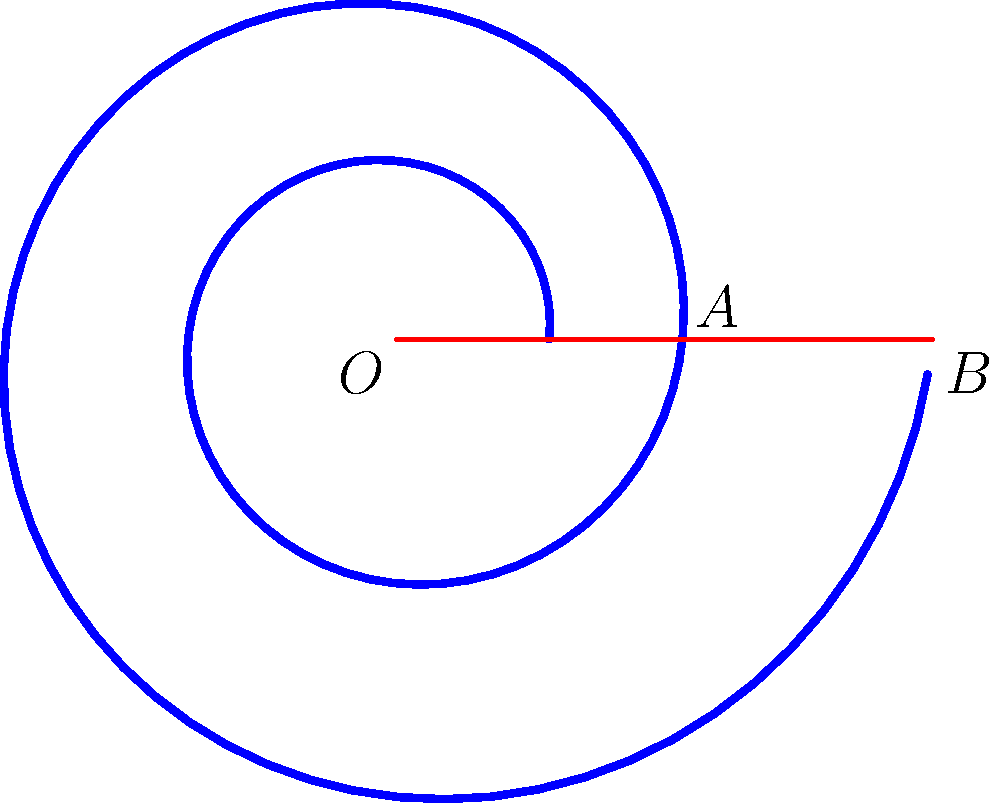In this spiral motif inspired by African art, point $A$ represents the end of the first complete rotation, and point $B$ represents the end of the second complete rotation. If the distance $OA$ is 2 cm and $OB$ is 4 cm, what is the angle of rotation (in degrees) between successive arms of the spiral? To find the angle of rotation between successive arms of the spiral, we can follow these steps:

1) In a logarithmic spiral, the distance from the center increases exponentially with each rotation. We can express this relationship as:

   $r = ae^{b\theta}$

   where $r$ is the distance from the center, $a$ is the initial radius, $b$ is the growth factor, and $\theta$ is the angle in radians.

2) We know two points on the spiral:
   - Point $A$: $\theta_1 = 2\pi$, $r_1 = 2$ cm
   - Point $B$: $\theta_2 = 4\pi$, $r_2 = 4$ cm

3) We can set up two equations:
   $2 = ae^{2\pi b}$
   $4 = ae^{4\pi b}$

4) Dividing the second equation by the first:
   $\frac{4}{2} = \frac{ae^{4\pi b}}{ae^{2\pi b}} = e^{2\pi b}$

5) Simplifying:
   $2 = e^{2\pi b}$

6) Taking the natural log of both sides:
   $\ln 2 = 2\pi b$

7) Solving for $b$:
   $b = \frac{\ln 2}{2\pi} \approx 0.11$

8) The angle of rotation between successive arms is the angle needed for the radius to double. We can find this by solving:
   $2 = e^{b\theta}$

9) Taking the natural log of both sides:
   $\ln 2 = b\theta$

10) Solving for $\theta$:
    $\theta = \frac{\ln 2}{b} = \frac{\ln 2}{\frac{\ln 2}{2\pi}} = 2\pi$

11) Converting to degrees:
    $2\pi$ radians = $360°$

Therefore, the angle of rotation between successive arms of the spiral is 360°.
Answer: 360° 